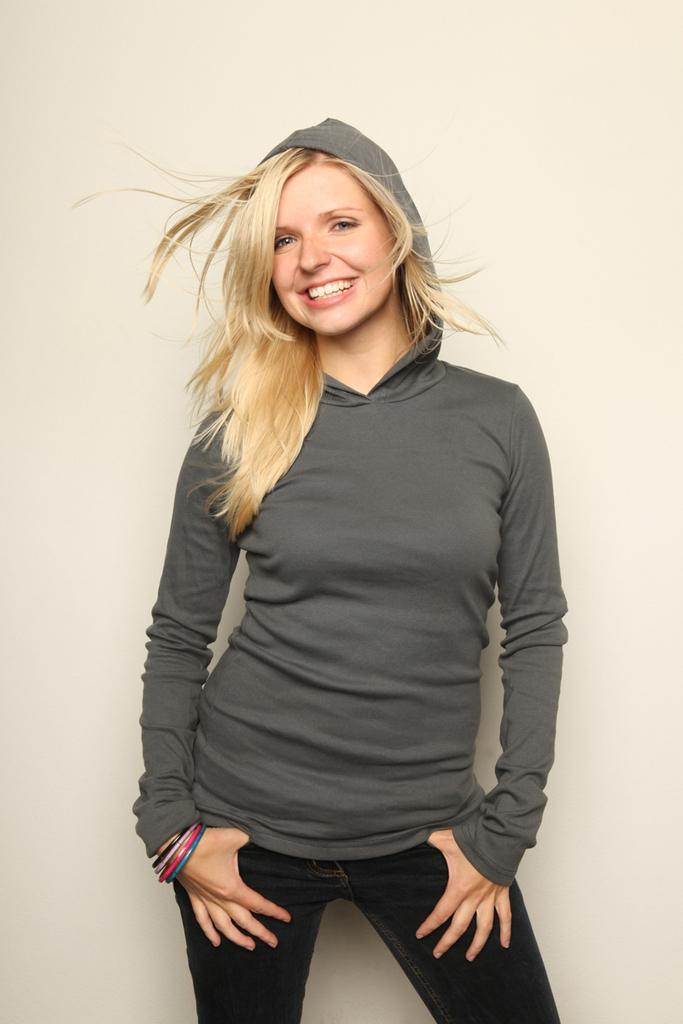What is the main subject of the image? There is a lady person in the image. What is the lady person wearing? The lady person is wearing a grey color hoodie and black color pants. What is the lady person doing in the image? The lady person is standing and posing for a photograph. Is the lady person sinking in quicksand in the image? No, there is no quicksand present in the image, and the lady person is standing on a solid surface. What type of ball is the lady person holding in the image? There is no ball present in the image; the lady person is simply posing for a photograph. 